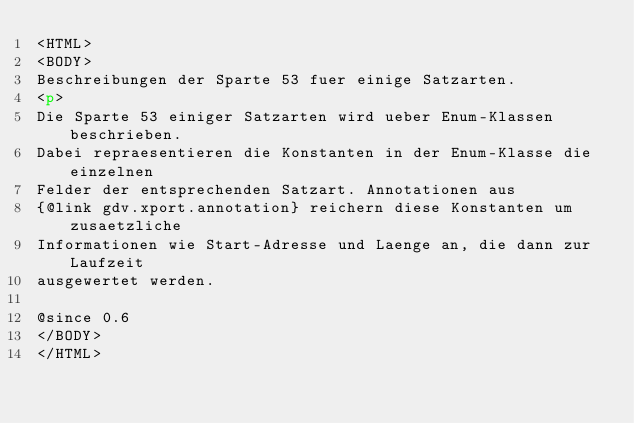Convert code to text. <code><loc_0><loc_0><loc_500><loc_500><_HTML_><HTML>
<BODY>
Beschreibungen der Sparte 53 fuer einige Satzarten.
<p>
Die Sparte 53 einiger Satzarten wird ueber Enum-Klassen beschrieben.
Dabei repraesentieren die Konstanten in der Enum-Klasse die einzelnen
Felder der entsprechenden Satzart. Annotationen aus
{@link gdv.xport.annotation} reichern diese Konstanten um zusaetzliche
Informationen wie Start-Adresse und Laenge an, die dann zur Laufzeit
ausgewertet werden.

@since 0.6
</BODY>
</HTML>
</code> 